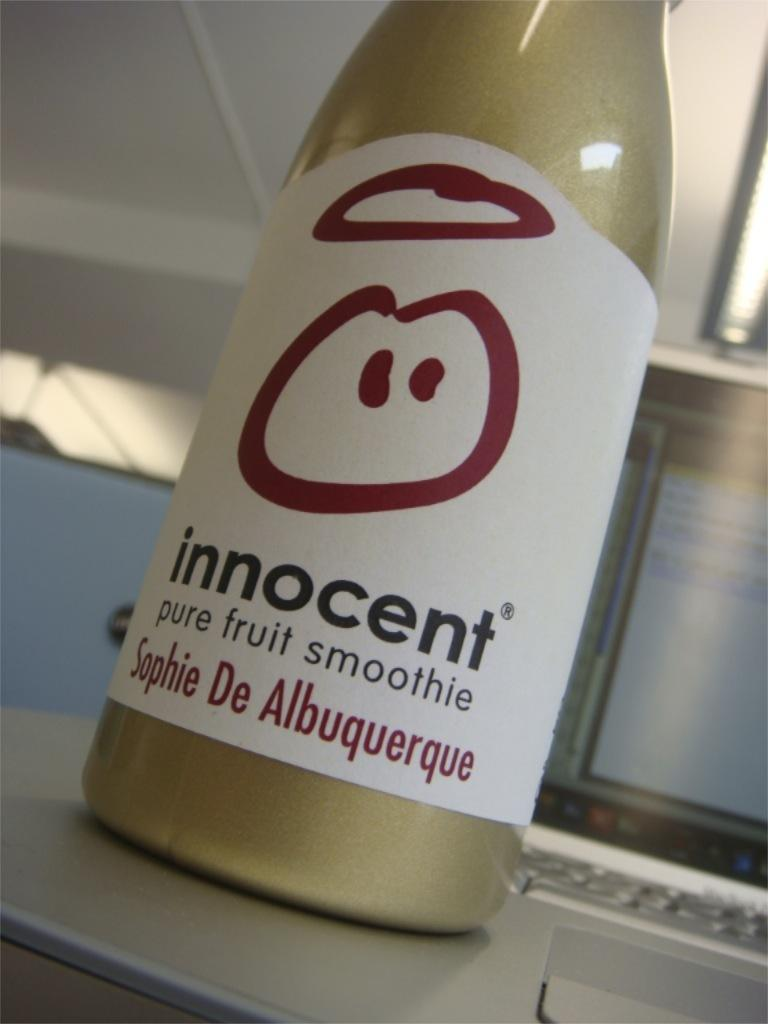What is on the bottle that is visible in the image? There is a label on the bottle in the image. Where is the bottle placed in the image? The bottle is placed on a laptop in the image. What can be seen in the background of the image? The background of the image is blurred. What type of lighting is present in the image? Ceiling lights are visible in the image. What part of the room is visible in the image? The ceiling is present in the image. How many apples are placed on the furniture in the image? There are no apples or furniture present in the image. What type of umbrella is being used to shield the laptop from the rain in the image? There is no umbrella or rain present in the image; the laptop is placed on a desk or table. 